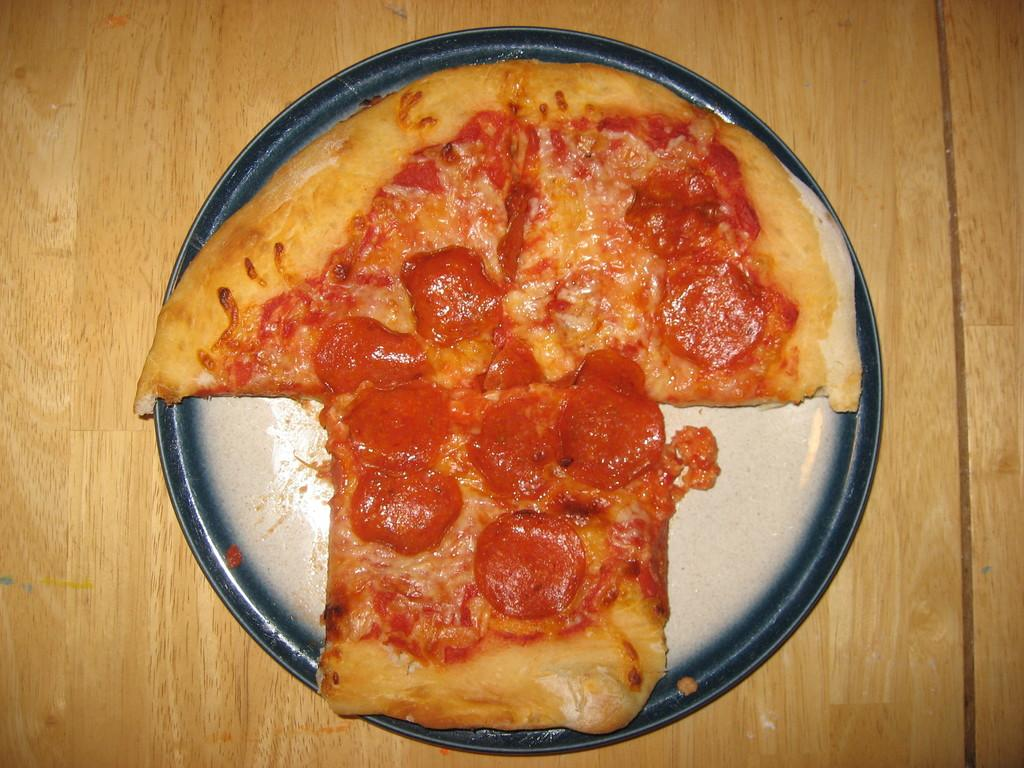What is present on the plate in the image? There is a food item on the plate in the image. What can be inferred about the material of the surface the plate is on? The surface the plate is on appears to be made of wood. How does the knee of the person in the image relate to the food on the plate? There is no person or knee present in the image; it only features a plate with a food item on it and a wooden surface. 